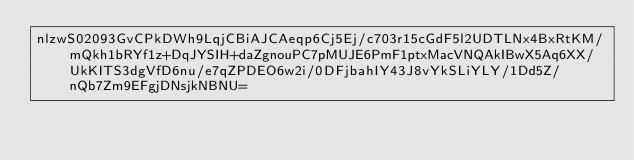Convert code to text. <code><loc_0><loc_0><loc_500><loc_500><_SML_>nlzwS02093GvCPkDWh9LqjCBiAJCAeqp6Cj5Ej/c703r15cGdF5l2UDTLNx4BxRtKM/mQkh1bRYf1z+DqJYSIH+daZgnouPC7pMUJE6PmF1ptxMacVNQAkIBwX5Aq6XX/UkKITS3dgVfD6nu/e7qZPDEO6w2i/0DFjbahIY43J8vYkSLiYLY/1Dd5Z/nQb7Zm9EFgjDNsjkNBNU=</code> 